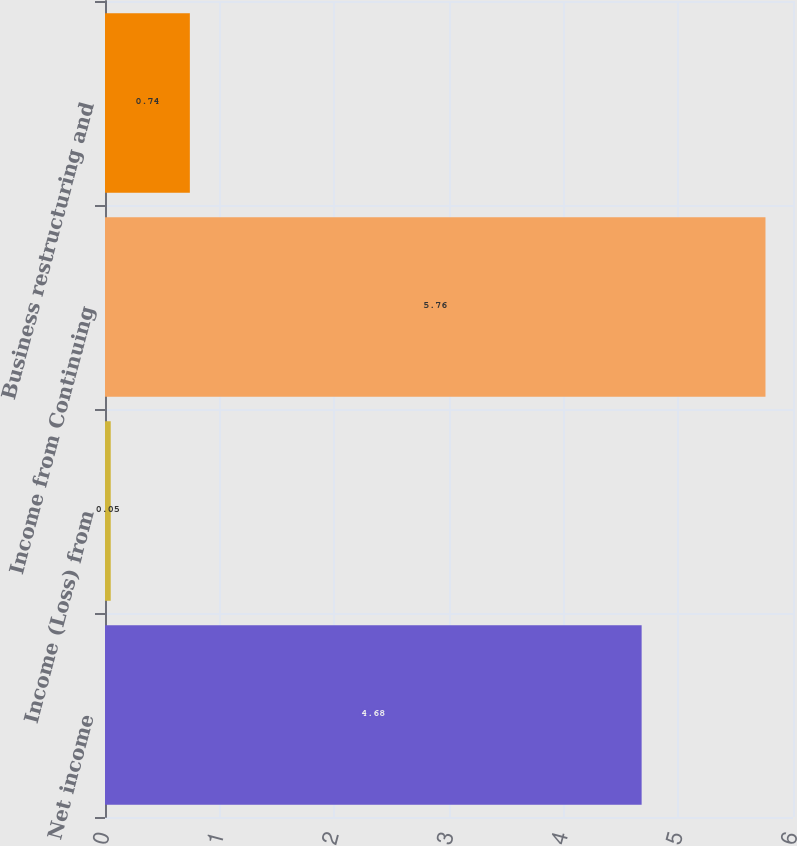<chart> <loc_0><loc_0><loc_500><loc_500><bar_chart><fcel>Net income<fcel>Income (Loss) from<fcel>Income from Continuing<fcel>Business restructuring and<nl><fcel>4.68<fcel>0.05<fcel>5.76<fcel>0.74<nl></chart> 